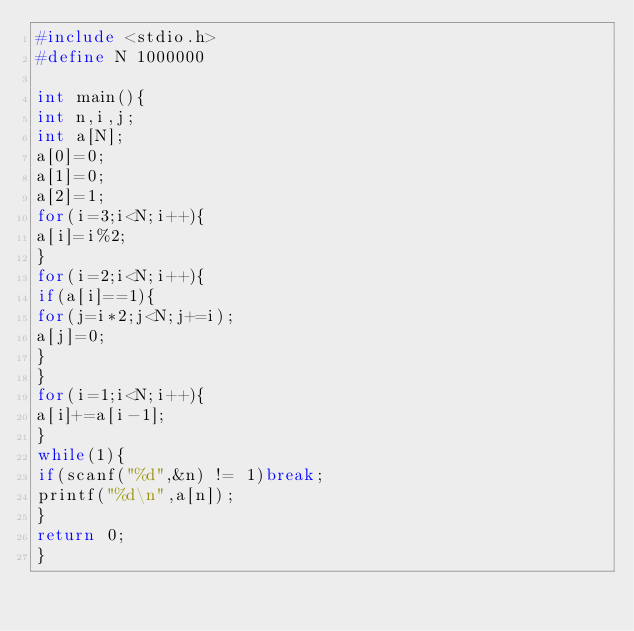<code> <loc_0><loc_0><loc_500><loc_500><_C_>#include <stdio.h>
#define N 1000000

int main(){
int n,i,j;
int a[N];
a[0]=0;
a[1]=0;
a[2]=1;
for(i=3;i<N;i++){
a[i]=i%2;
}
for(i=2;i<N;i++){
if(a[i]==1){
for(j=i*2;j<N;j+=i);
a[j]=0;
}
}
for(i=1;i<N;i++){
a[i]+=a[i-1];
}
while(1){
if(scanf("%d",&n) != 1)break;
printf("%d\n",a[n]);
}
return 0;
}</code> 